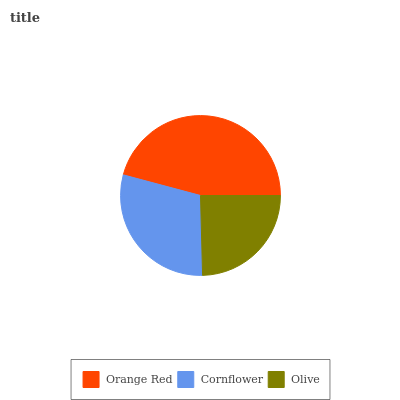Is Olive the minimum?
Answer yes or no. Yes. Is Orange Red the maximum?
Answer yes or no. Yes. Is Cornflower the minimum?
Answer yes or no. No. Is Cornflower the maximum?
Answer yes or no. No. Is Orange Red greater than Cornflower?
Answer yes or no. Yes. Is Cornflower less than Orange Red?
Answer yes or no. Yes. Is Cornflower greater than Orange Red?
Answer yes or no. No. Is Orange Red less than Cornflower?
Answer yes or no. No. Is Cornflower the high median?
Answer yes or no. Yes. Is Cornflower the low median?
Answer yes or no. Yes. Is Orange Red the high median?
Answer yes or no. No. Is Olive the low median?
Answer yes or no. No. 